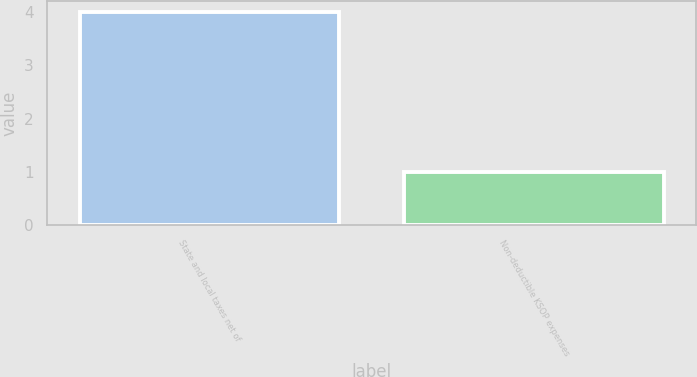<chart> <loc_0><loc_0><loc_500><loc_500><bar_chart><fcel>State and local taxes net of<fcel>Non-deductible KSOP expenses<nl><fcel>4<fcel>1<nl></chart> 